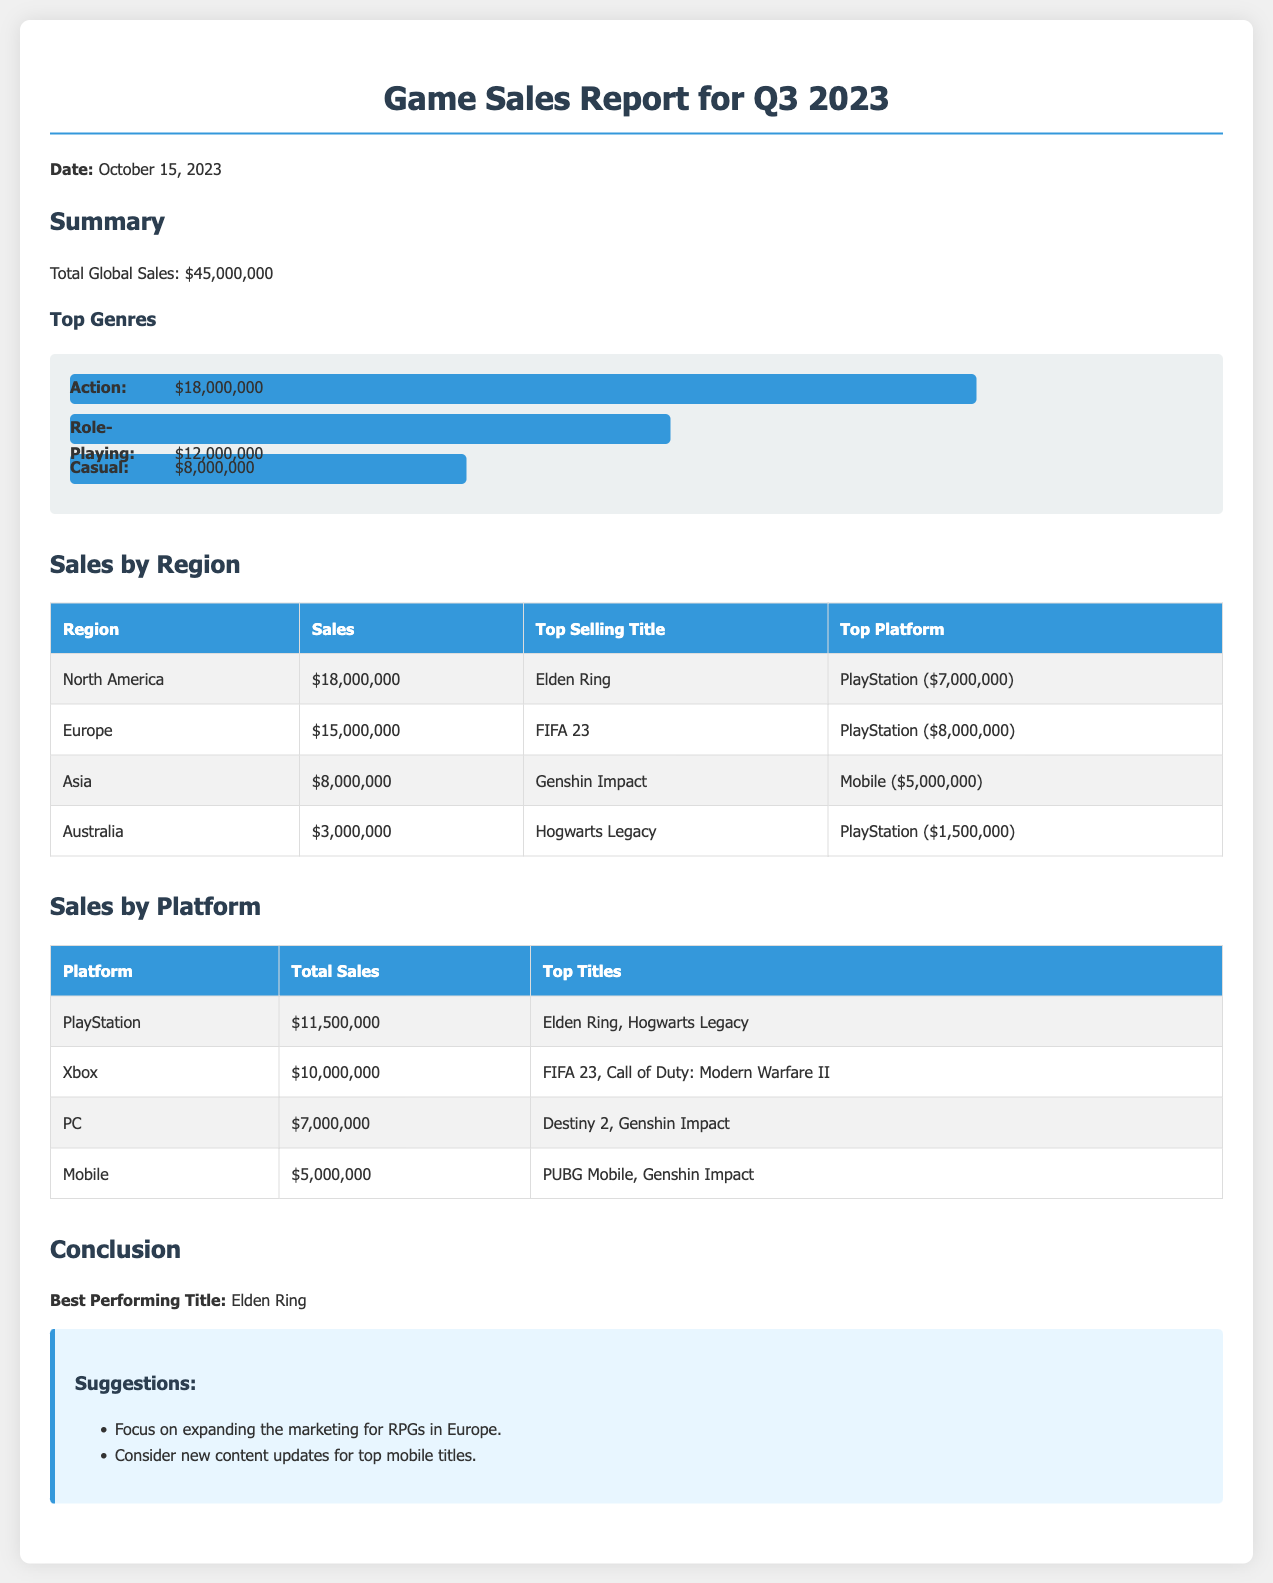What is the total global sales? The total global sales are stated clearly in the summary section of the document, which lists it as $45,000,000.
Answer: $45,000,000 What is the top selling title in North America? The document specifies that the top selling title in North America is Elden Ring, as indicated in the regional sales section.
Answer: Elden Ring How much did PlayStation sales amount to in Europe? The document notes that PlayStation sales in Europe totaled $8,000,000, as per the sales by region section.
Answer: $8,000,000 Which platform generated the highest total sales? By reviewing the sales by platform section, it is found that PlayStation generated the highest total sales of $11,500,000.
Answer: PlayStation What is the best performing title overall? The conclusion of the document presents Elden Ring as the best performing title based on its sales performance.
Answer: Elden Ring How much did mobile games generate in total sales? The sales by platform section indicates that mobile games generated total sales of $5,000,000.
Answer: $5,000,000 Which region had the lowest sales? Reviewing the sales by region table, Australia is identified as the region with the lowest sales of $3,000,000.
Answer: Australia What is the second top genre by sales? Analyzing the chart in the summary, Role-Playing ranks as the second top genre by sales at $12,000,000.
Answer: Role-Playing 